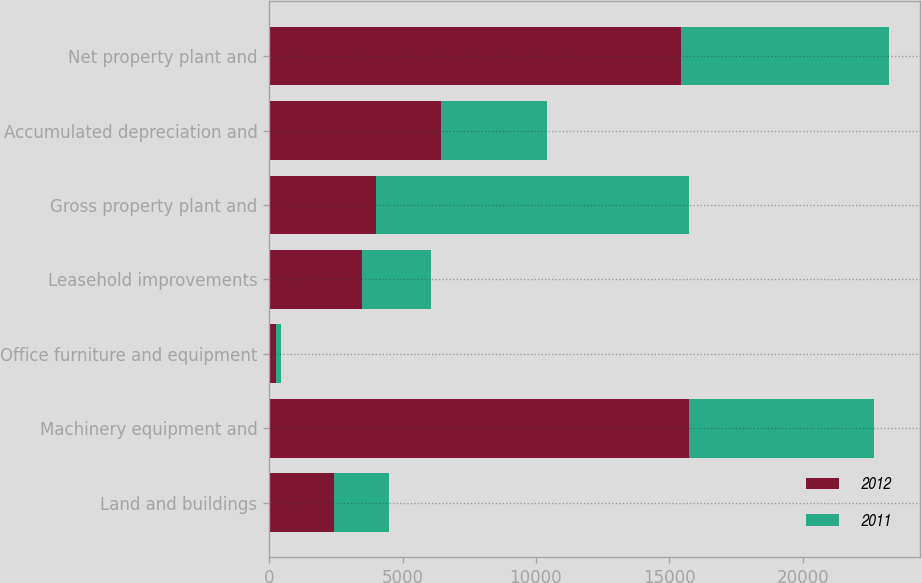Convert chart to OTSL. <chart><loc_0><loc_0><loc_500><loc_500><stacked_bar_chart><ecel><fcel>Land and buildings<fcel>Machinery equipment and<fcel>Office furniture and equipment<fcel>Leasehold improvements<fcel>Gross property plant and<fcel>Accumulated depreciation and<fcel>Net property plant and<nl><fcel>2012<fcel>2439<fcel>15743<fcel>241<fcel>3464<fcel>3991<fcel>6435<fcel>15452<nl><fcel>2011<fcel>2059<fcel>6926<fcel>184<fcel>2599<fcel>11768<fcel>3991<fcel>7777<nl></chart> 